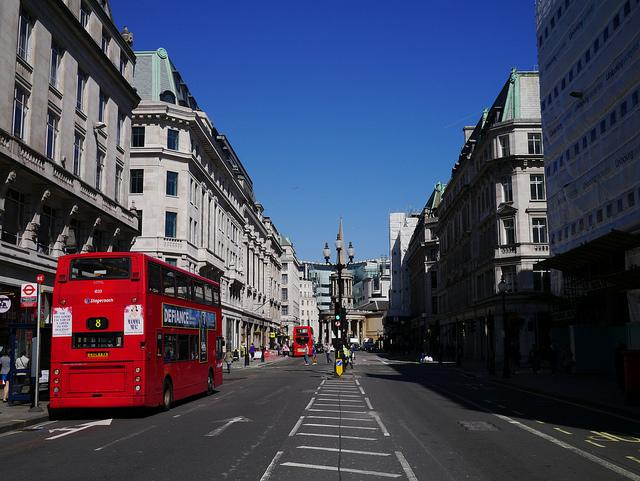How many double-decker buses are loading on the left side of the street? two 